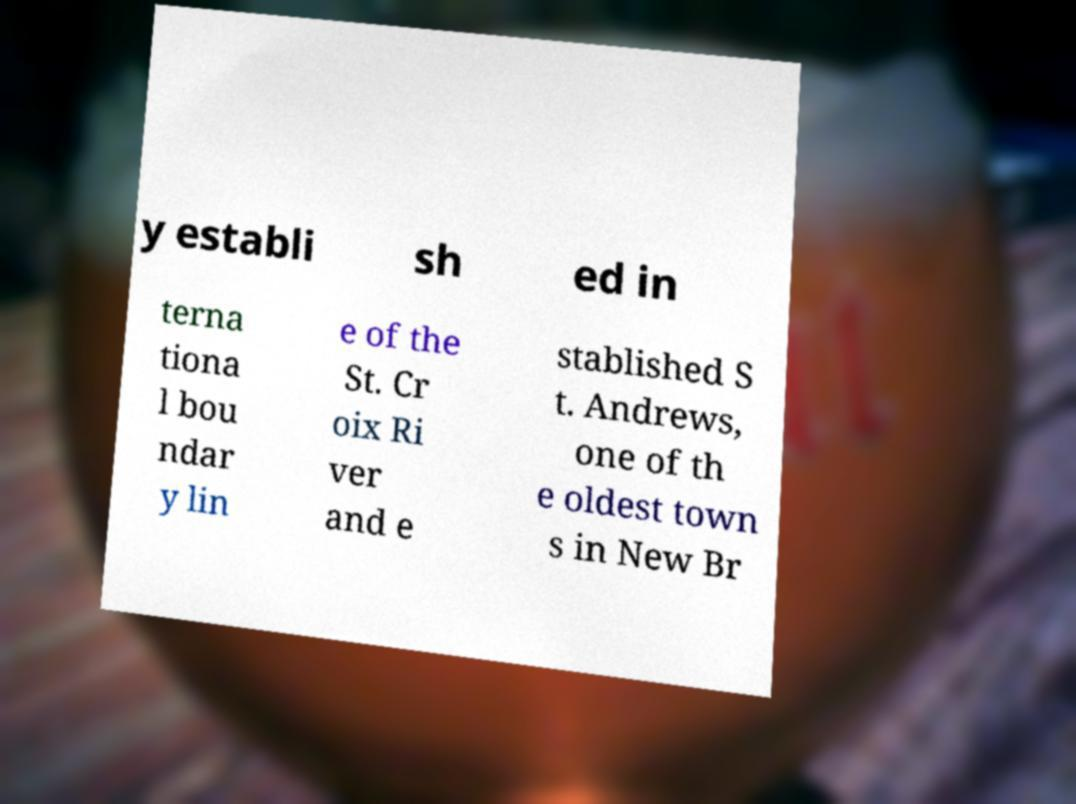Please read and relay the text visible in this image. What does it say? y establi sh ed in terna tiona l bou ndar y lin e of the St. Cr oix Ri ver and e stablished S t. Andrews, one of th e oldest town s in New Br 